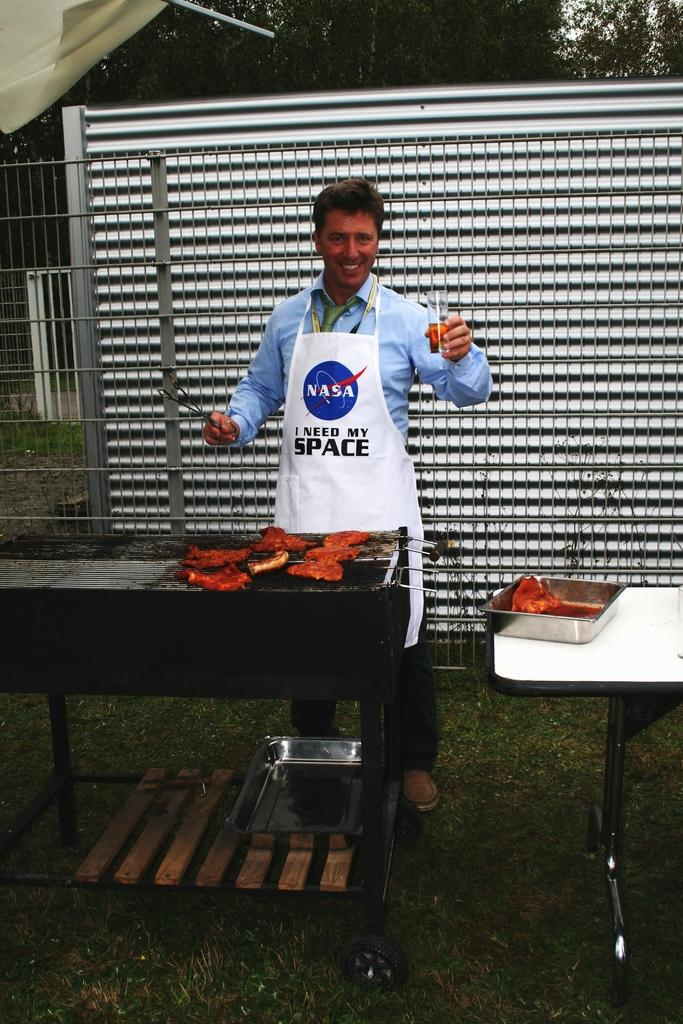Provide a one-sentence caption for the provided image. A man is cooking at a barbecue with a NASA apron that says I Need My Space. 